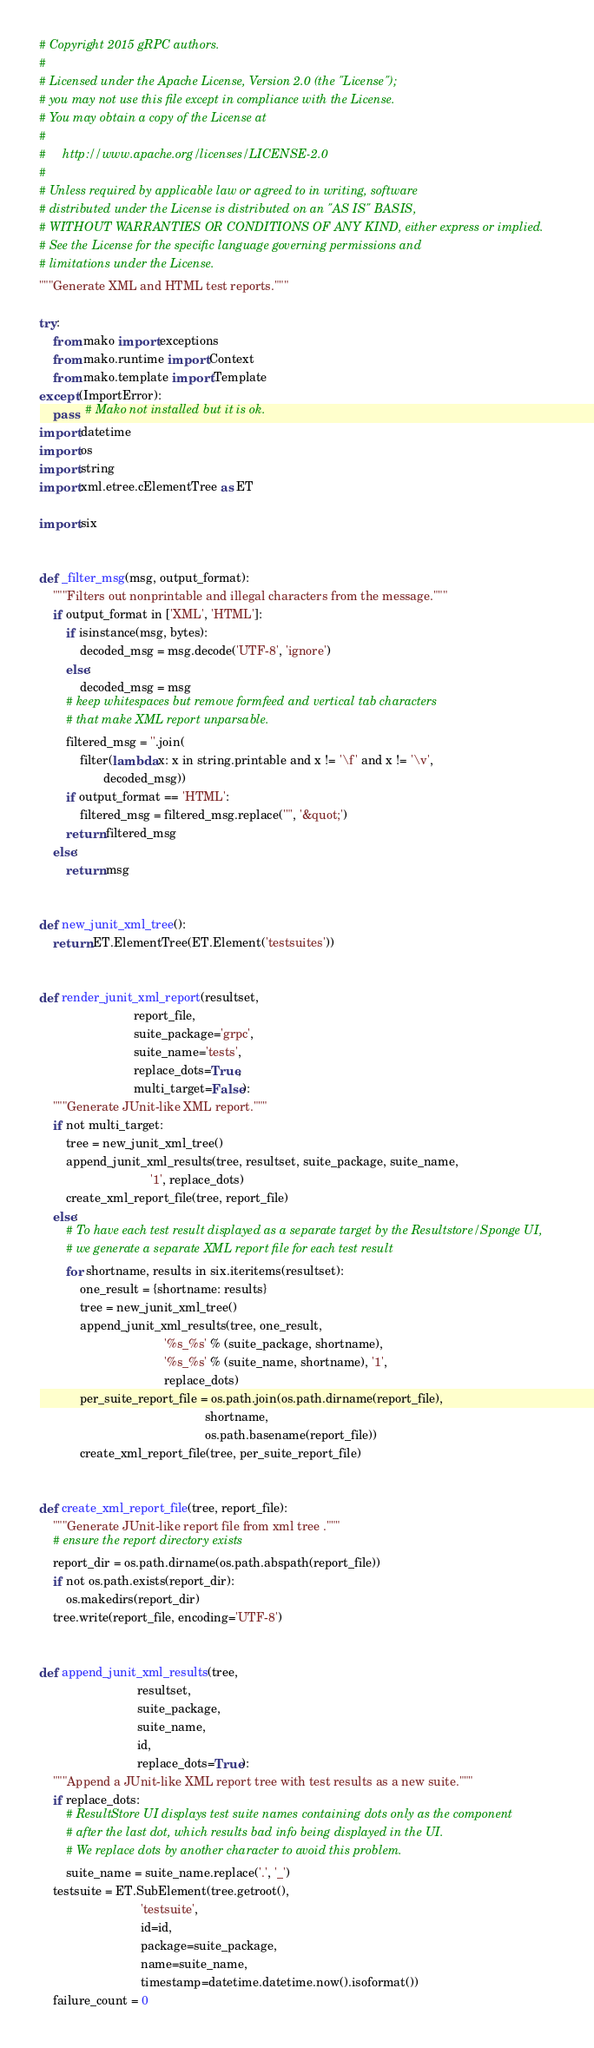<code> <loc_0><loc_0><loc_500><loc_500><_Python_># Copyright 2015 gRPC authors.
#
# Licensed under the Apache License, Version 2.0 (the "License");
# you may not use this file except in compliance with the License.
# You may obtain a copy of the License at
#
#     http://www.apache.org/licenses/LICENSE-2.0
#
# Unless required by applicable law or agreed to in writing, software
# distributed under the License is distributed on an "AS IS" BASIS,
# WITHOUT WARRANTIES OR CONDITIONS OF ANY KIND, either express or implied.
# See the License for the specific language governing permissions and
# limitations under the License.
"""Generate XML and HTML test reports."""

try:
    from mako import exceptions
    from mako.runtime import Context
    from mako.template import Template
except (ImportError):
    pass  # Mako not installed but it is ok.
import datetime
import os
import string
import xml.etree.cElementTree as ET

import six


def _filter_msg(msg, output_format):
    """Filters out nonprintable and illegal characters from the message."""
    if output_format in ['XML', 'HTML']:
        if isinstance(msg, bytes):
            decoded_msg = msg.decode('UTF-8', 'ignore')
        else:
            decoded_msg = msg
        # keep whitespaces but remove formfeed and vertical tab characters
        # that make XML report unparsable.
        filtered_msg = ''.join(
            filter(lambda x: x in string.printable and x != '\f' and x != '\v',
                   decoded_msg))
        if output_format == 'HTML':
            filtered_msg = filtered_msg.replace('"', '&quot;')
        return filtered_msg
    else:
        return msg


def new_junit_xml_tree():
    return ET.ElementTree(ET.Element('testsuites'))


def render_junit_xml_report(resultset,
                            report_file,
                            suite_package='grpc',
                            suite_name='tests',
                            replace_dots=True,
                            multi_target=False):
    """Generate JUnit-like XML report."""
    if not multi_target:
        tree = new_junit_xml_tree()
        append_junit_xml_results(tree, resultset, suite_package, suite_name,
                                 '1', replace_dots)
        create_xml_report_file(tree, report_file)
    else:
        # To have each test result displayed as a separate target by the Resultstore/Sponge UI,
        # we generate a separate XML report file for each test result
        for shortname, results in six.iteritems(resultset):
            one_result = {shortname: results}
            tree = new_junit_xml_tree()
            append_junit_xml_results(tree, one_result,
                                     '%s_%s' % (suite_package, shortname),
                                     '%s_%s' % (suite_name, shortname), '1',
                                     replace_dots)
            per_suite_report_file = os.path.join(os.path.dirname(report_file),
                                                 shortname,
                                                 os.path.basename(report_file))
            create_xml_report_file(tree, per_suite_report_file)


def create_xml_report_file(tree, report_file):
    """Generate JUnit-like report file from xml tree ."""
    # ensure the report directory exists
    report_dir = os.path.dirname(os.path.abspath(report_file))
    if not os.path.exists(report_dir):
        os.makedirs(report_dir)
    tree.write(report_file, encoding='UTF-8')


def append_junit_xml_results(tree,
                             resultset,
                             suite_package,
                             suite_name,
                             id,
                             replace_dots=True):
    """Append a JUnit-like XML report tree with test results as a new suite."""
    if replace_dots:
        # ResultStore UI displays test suite names containing dots only as the component
        # after the last dot, which results bad info being displayed in the UI.
        # We replace dots by another character to avoid this problem.
        suite_name = suite_name.replace('.', '_')
    testsuite = ET.SubElement(tree.getroot(),
                              'testsuite',
                              id=id,
                              package=suite_package,
                              name=suite_name,
                              timestamp=datetime.datetime.now().isoformat())
    failure_count = 0</code> 